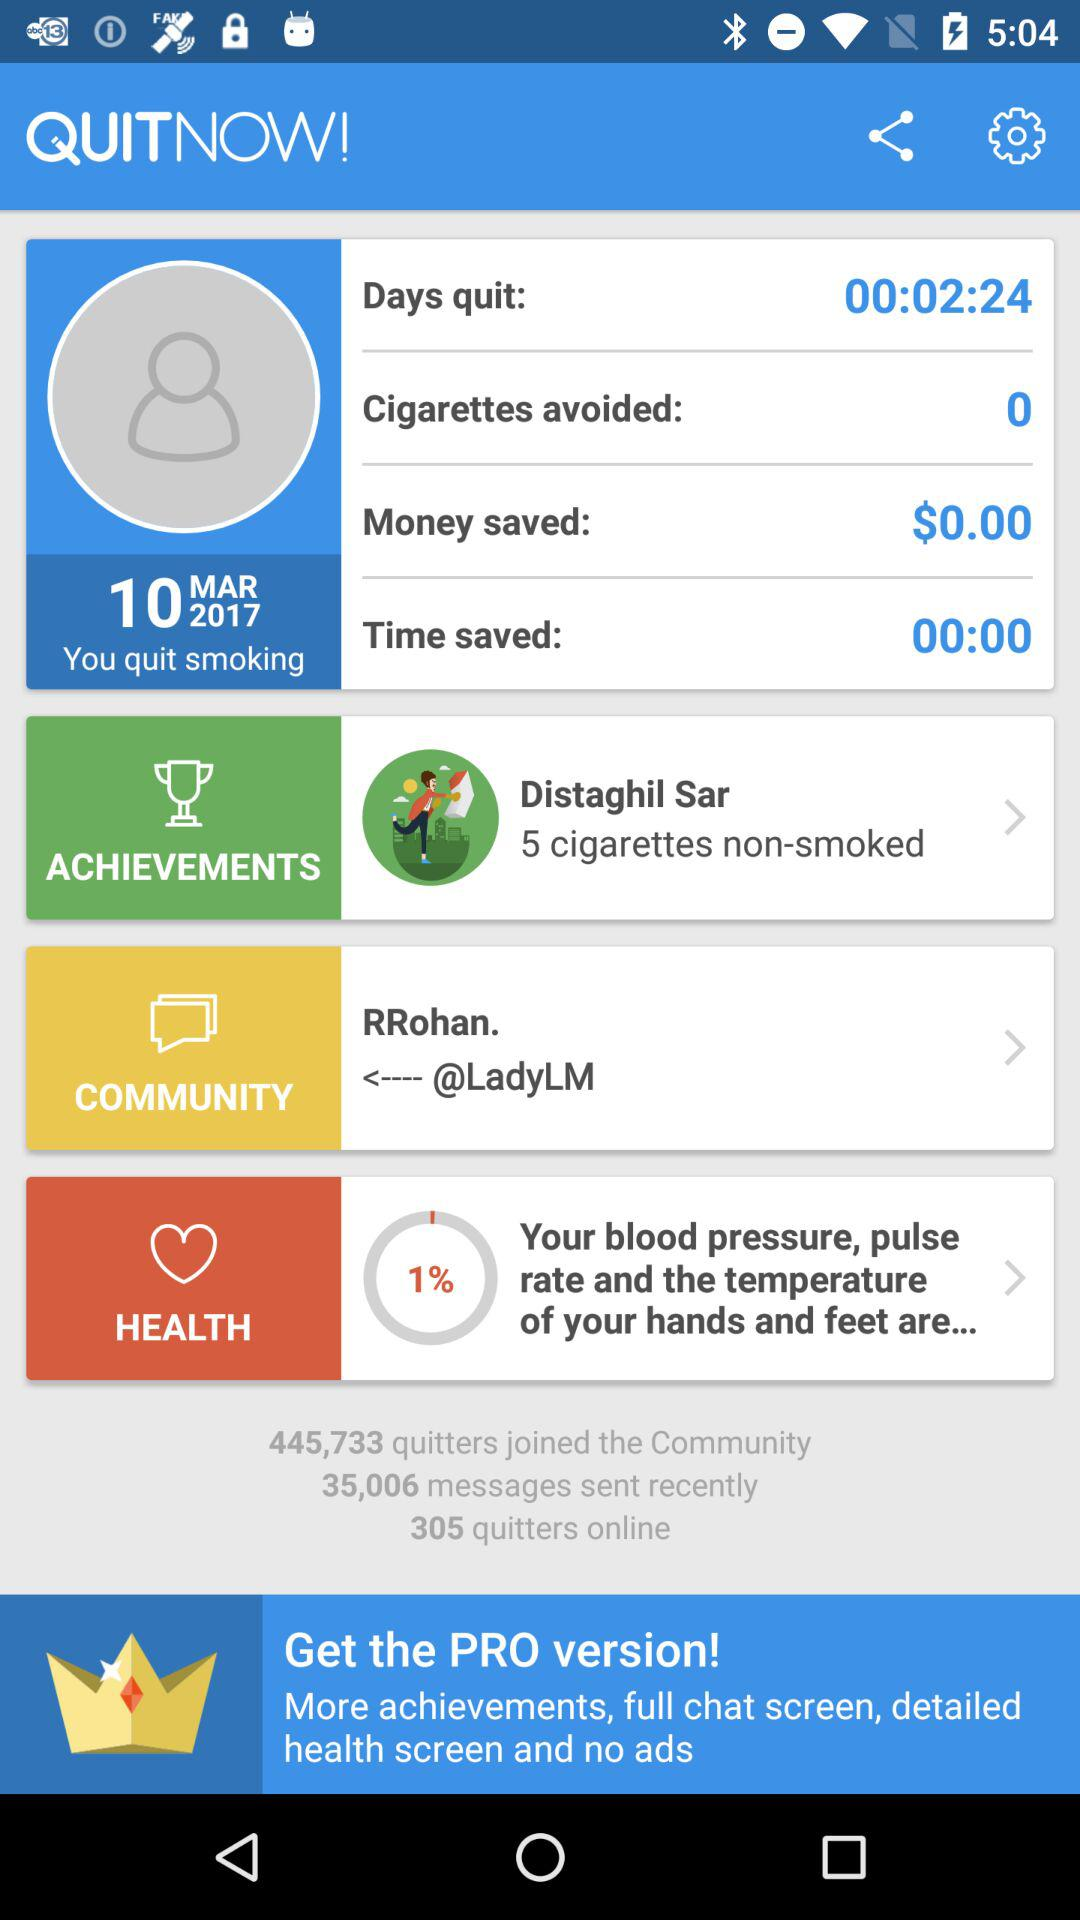How many messages were sent recently? There were 35,006 messages sent recently. 